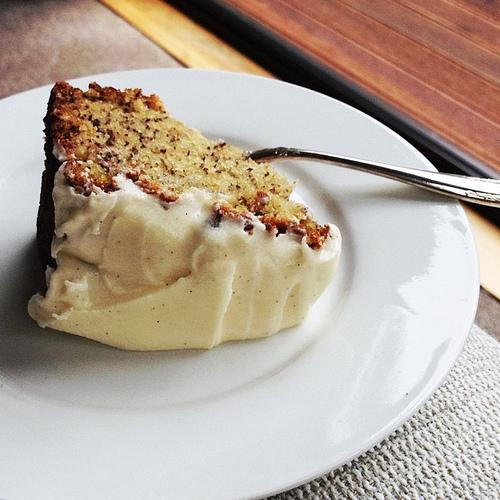What are the three prominent colors on this cake? The cake has the colors yellow, brown, and white. In simple words, tell me what the main focus of the image is. A tempting slice of cake with white frosting is resting on a white ceramic plate with a fork nearby. Which task would be useful for automatically identifying the objects and surface details in the image? Image segmentation task. Identify the surface upon which the plate is resting, and describe it in as much detail as possible. The plate is resting on a wooden table with a white, woven table mat underneath it. What kind of food is served in this image? Also, mention the texture of the food. There's a piece of yellow cake served with white, creamy frosting. The texture of the cake appears rough, not smooth. How does the cake in the image deviate from a perfect triangular shape? Also, mention if any part of the cake is uneaten. The cake is irregularly shaped and has a rough texture. A piece of the cake appears to be eaten. Can you describe the utensil in the image? How does it look? There's a shiny, silver fork placed next to the cake on the plate. Which task could help in understanding the emotional response of people to the image? Image sentiment analysis task. Which task would be appropriate to understand the overall context and attributes of various elements in the image? Image context analysis task. If you were to detect any unusual elements in this image, which task would be suitable? Image anomaly detection task. Notice the half-eaten slice of cake with missing pieces. The captions mention a piece of the cake has been eaten, but it doesn't say the cake itself is half-eaten or has missing pieces. Don't you just love the exquisite artwork on the plate's rim? There is no mention of any artwork on the white ceramic plate in the captions. Can you see the perfectly round shape of the cake? The cake is described as triangular and irregularly shaped, not perfectly round. Pay attention to the large green salad next to the dessert. There is no mention of any salad, green or otherwise, in the image captions. Observe the metallic fork with an intricate handle design. The fork is described as shiny, but there is no mention of it having an intricate handle design. Please notice the bright blue plate the cake is on. The plate mentioned in the captions is described as white, not bright blue. Can you spot the fluffy pink frosting on the cake? The frosting on the cake is described as white and creamy, not fluffy and pink. Isn't the polka-dotted table mat underneath the white plate lovely? The table mat is mentioned as woven, there is no mention of being polka-dotted. Find the tall glass of milk to accompany the cake. There is no mention of a glass of milk in the image captions. Find the smooth and shiny surface of the cake. It's mentioned that the cake's texture is rough instead of smooth. 